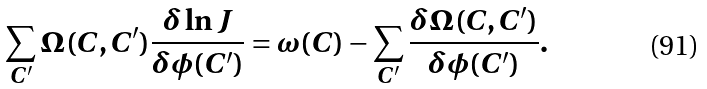<formula> <loc_0><loc_0><loc_500><loc_500>\sum _ { C ^ { \prime } } \Omega ( C , C ^ { \prime } ) { \frac { \delta \ln J } { \delta \phi ( C ^ { \prime } ) } } = \omega ( C ) - \sum _ { C ^ { \prime } } { \frac { \delta \Omega ( C , C ^ { \prime } ) } { \delta \phi ( C ^ { \prime } ) } } .</formula> 